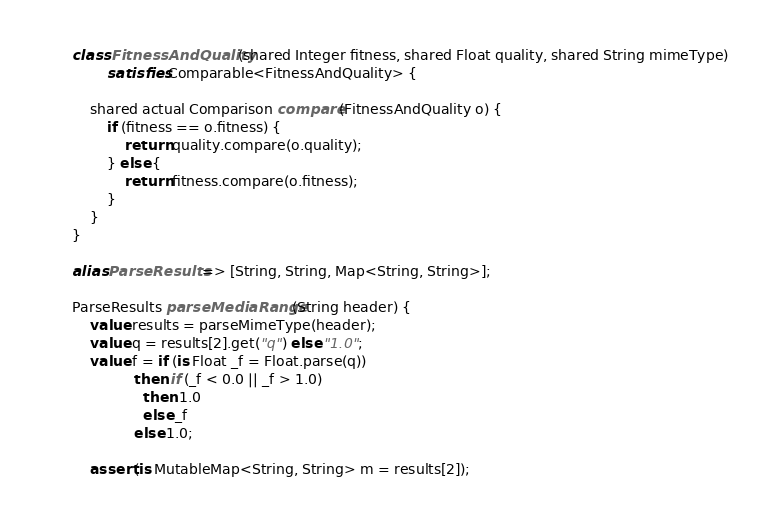Convert code to text. <code><loc_0><loc_0><loc_500><loc_500><_Ceylon_>
    class FitnessAndQuality(shared Integer fitness, shared Float quality, shared String mimeType)
            satisfies Comparable<FitnessAndQuality> {
        
        shared actual Comparison compare(FitnessAndQuality o) {
            if (fitness == o.fitness) {
                return quality.compare(o.quality);
            } else {
                return fitness.compare(o.fitness);
            }
        }
    }
    
    alias ParseResults => [String, String, Map<String, String>];
    
    ParseResults parseMediaRange(String header) {
        value results = parseMimeType(header);
        value q = results[2].get("q") else "1.0";
        value f = if (is Float _f = Float.parse(q))
                  then if (_f < 0.0 || _f > 1.0)
                    then 1.0
                    else _f
                  else 1.0;
        
        assert(is MutableMap<String, String> m = results[2]);</code> 